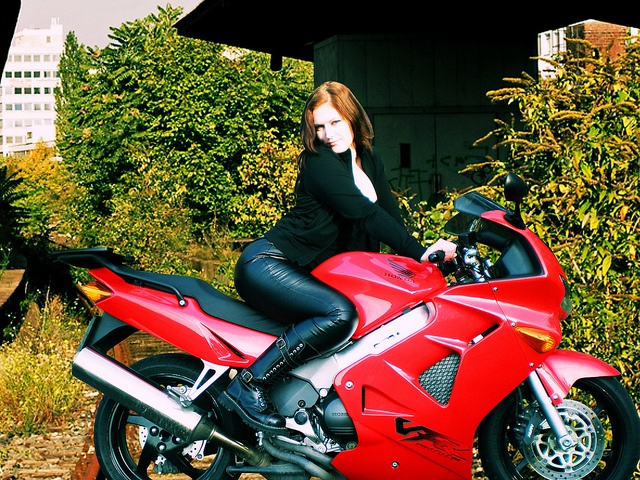Describe the objects in this image and their specific colors. I can see motorcycle in black, red, lavender, and teal tones and people in black, blue, white, and darkblue tones in this image. 